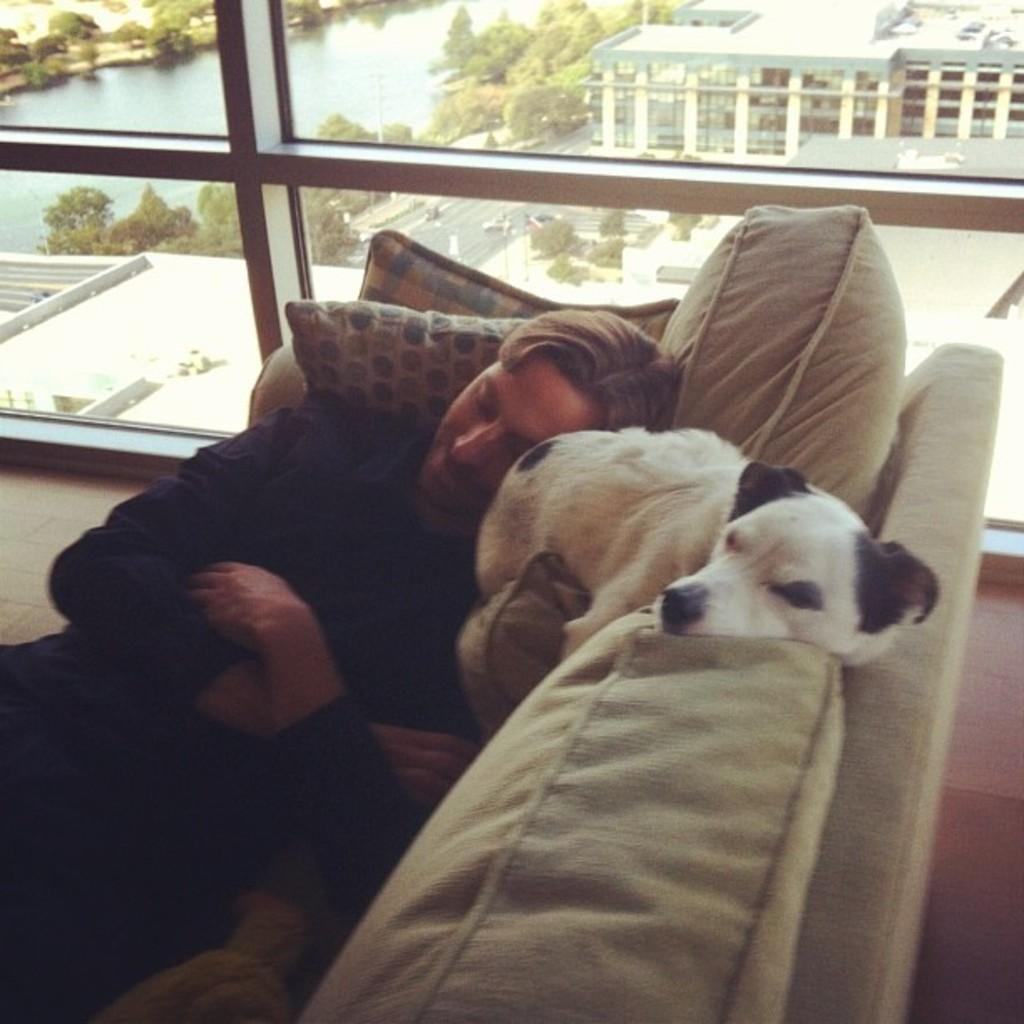What is present in the image along with the man? There is a dog in the image along with the man. What are the man and the dog doing in the image? Both the man and the dog are sleeping in the image. Where are the man and the dog sleeping? They are sleeping on a sofa in the image. What can be seen in the background of the image? There is a glass window in the image. What type of poison is the man using on the dog's stem in the image? There is no poison, stem, or badge present in the image. What type of badge is the man wearing in the image? There is no badge present in the image. 